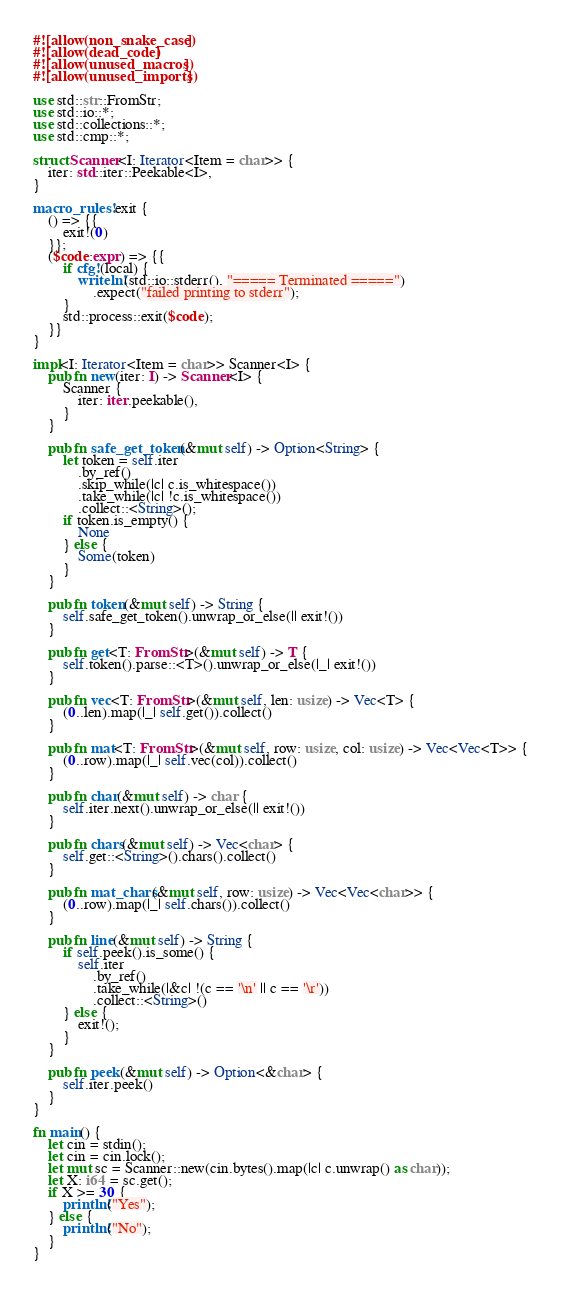<code> <loc_0><loc_0><loc_500><loc_500><_Rust_>#![allow(non_snake_case)]
#![allow(dead_code)]
#![allow(unused_macros)]
#![allow(unused_imports)]

use std::str::FromStr;
use std::io::*;
use std::collections::*;
use std::cmp::*;

struct Scanner<I: Iterator<Item = char>> {
    iter: std::iter::Peekable<I>,
}

macro_rules! exit {
    () => {{
        exit!(0)
    }};
    ($code:expr) => {{
        if cfg!(local) {
            writeln!(std::io::stderr(), "===== Terminated =====")
                .expect("failed printing to stderr");
        }
        std::process::exit($code);
    }}
}

impl<I: Iterator<Item = char>> Scanner<I> {
    pub fn new(iter: I) -> Scanner<I> {
        Scanner {
            iter: iter.peekable(),
        }
    }

    pub fn safe_get_token(&mut self) -> Option<String> {
        let token = self.iter
            .by_ref()
            .skip_while(|c| c.is_whitespace())
            .take_while(|c| !c.is_whitespace())
            .collect::<String>();
        if token.is_empty() {
            None
        } else {
            Some(token)
        }
    }

    pub fn token(&mut self) -> String {
        self.safe_get_token().unwrap_or_else(|| exit!())
    }

    pub fn get<T: FromStr>(&mut self) -> T {
        self.token().parse::<T>().unwrap_or_else(|_| exit!())
    }

    pub fn vec<T: FromStr>(&mut self, len: usize) -> Vec<T> {
        (0..len).map(|_| self.get()).collect()
    }

    pub fn mat<T: FromStr>(&mut self, row: usize, col: usize) -> Vec<Vec<T>> {
        (0..row).map(|_| self.vec(col)).collect()
    }

    pub fn char(&mut self) -> char {
        self.iter.next().unwrap_or_else(|| exit!())
    }

    pub fn chars(&mut self) -> Vec<char> {
        self.get::<String>().chars().collect()
    }

    pub fn mat_chars(&mut self, row: usize) -> Vec<Vec<char>> {
        (0..row).map(|_| self.chars()).collect()
    }

    pub fn line(&mut self) -> String {
        if self.peek().is_some() {
            self.iter
                .by_ref()
                .take_while(|&c| !(c == '\n' || c == '\r'))
                .collect::<String>()
        } else {
            exit!();
        }
    }

    pub fn peek(&mut self) -> Option<&char> {
        self.iter.peek()
    }
}

fn main() {
    let cin = stdin();
    let cin = cin.lock();
    let mut sc = Scanner::new(cin.bytes().map(|c| c.unwrap() as char));
    let X: i64 = sc.get();
    if X >= 30 {
        println!("Yes");
    } else {
        println!("No");
    }
}
</code> 